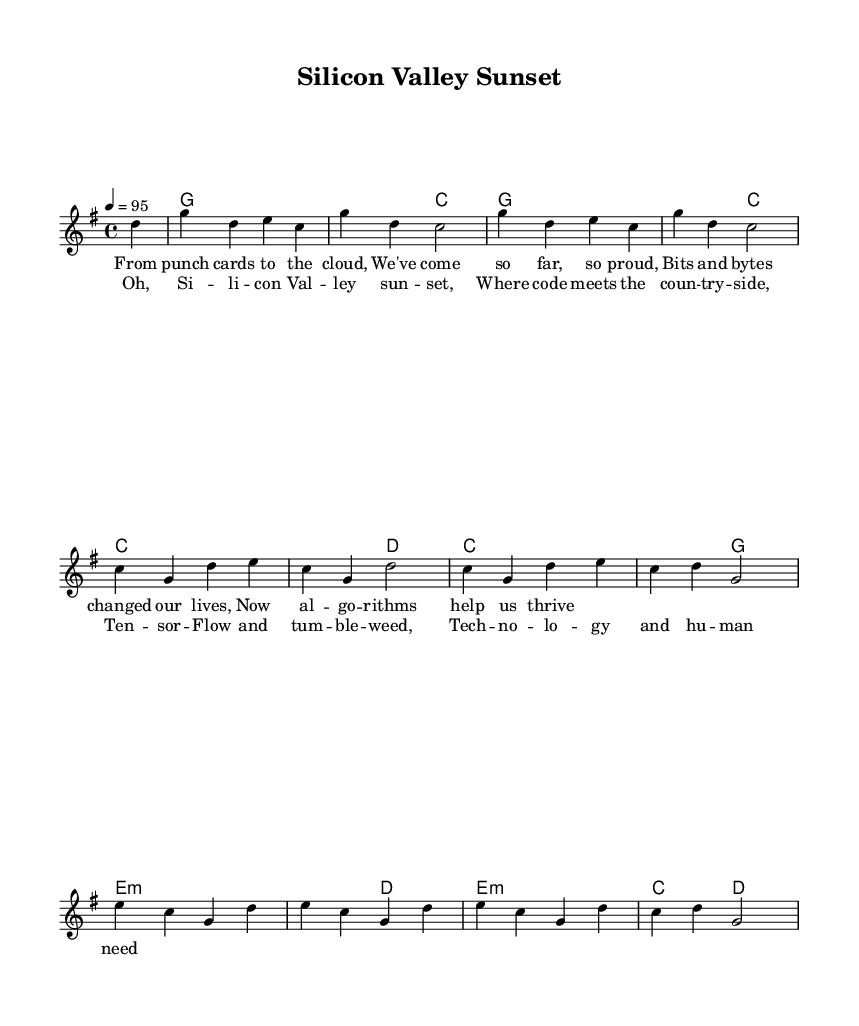What is the key signature of this music? The key signature is G major, which has one sharp (F#).
Answer: G major What is the time signature of this music? The time signature is 4/4, indicating four beats per measure.
Answer: 4/4 What is the tempo marking of this music? The tempo marking is 4 = 95, which indicates the speed at which the piece should be played.
Answer: 95 How many measures are in the verse? The verse consists of 8 measures, as indicated by the number of phrases and the alignment with the melody.
Answer: 8 Which musical element reflects the nostalgic aspect of the song? The lyrics reflect nostalgia through references to past technology, such as "punch cards" and "cloud."
Answer: Lyrics What type of chord is used in the second measure? The second measure has a G chord, which is a major chord composed of the notes G, B, and D.
Answer: G How does the chorus differ from the verse in terms of lyrical content? The chorus has a more emotive and reflective tone, capturing the technological theme with nature imagery.
Answer: Emotive tone 